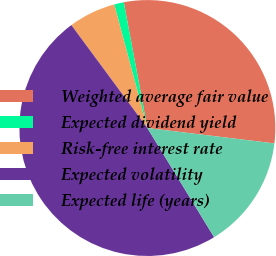Convert chart. <chart><loc_0><loc_0><loc_500><loc_500><pie_chart><fcel>Weighted average fair value<fcel>Expected dividend yield<fcel>Risk-free interest rate<fcel>Expected volatility<fcel>Expected life (years)<nl><fcel>29.87%<fcel>1.22%<fcel>5.96%<fcel>48.61%<fcel>14.35%<nl></chart> 